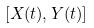<formula> <loc_0><loc_0><loc_500><loc_500>[ X ( t ) , Y ( t ) ]</formula> 